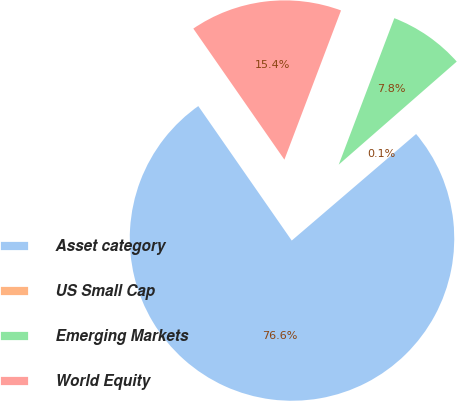<chart> <loc_0><loc_0><loc_500><loc_500><pie_chart><fcel>Asset category<fcel>US Small Cap<fcel>Emerging Markets<fcel>World Equity<nl><fcel>76.61%<fcel>0.15%<fcel>7.8%<fcel>15.44%<nl></chart> 